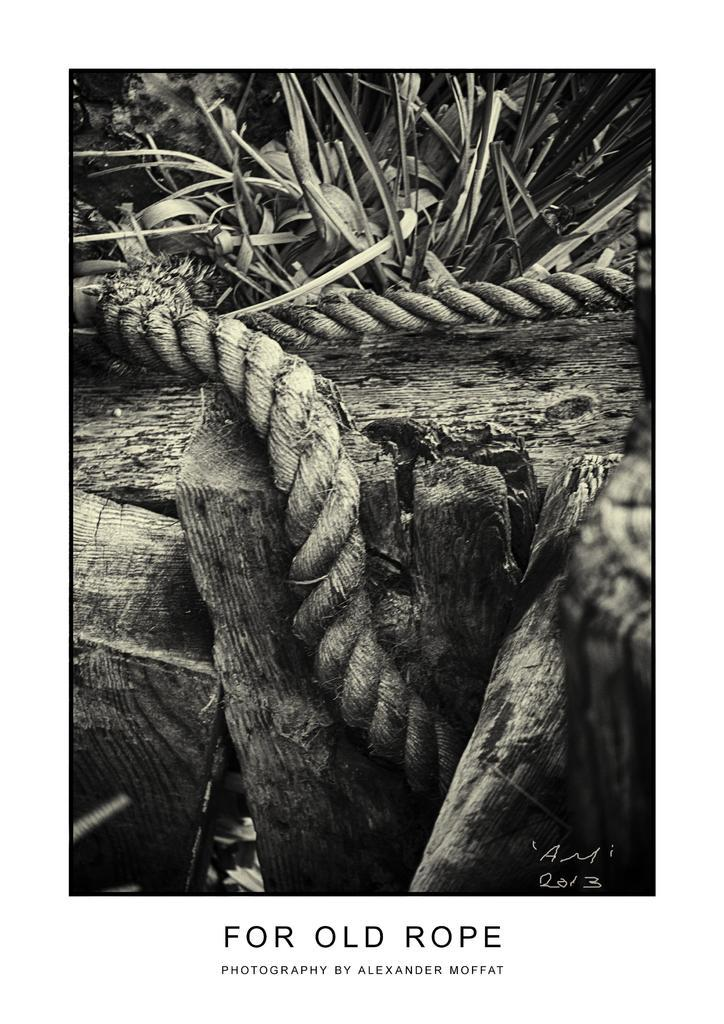What is the color scheme of the image? The image is black and white. What objects can be seen in the image? There are ropes and wooden logs in the image. What can be seen in the background of the image? There is a plant in the background of the image. Is there any text associated with the image? Yes, there is text written below the image. What type of celery is being used to create a voice in the image? There is no celery or voice present in the image. 